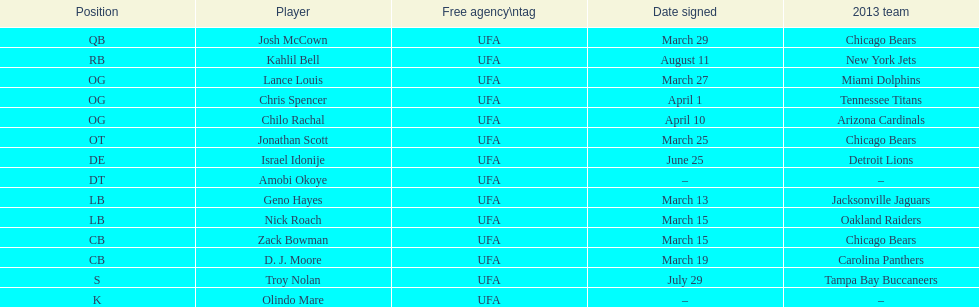The top played position according to this chart. OG. 